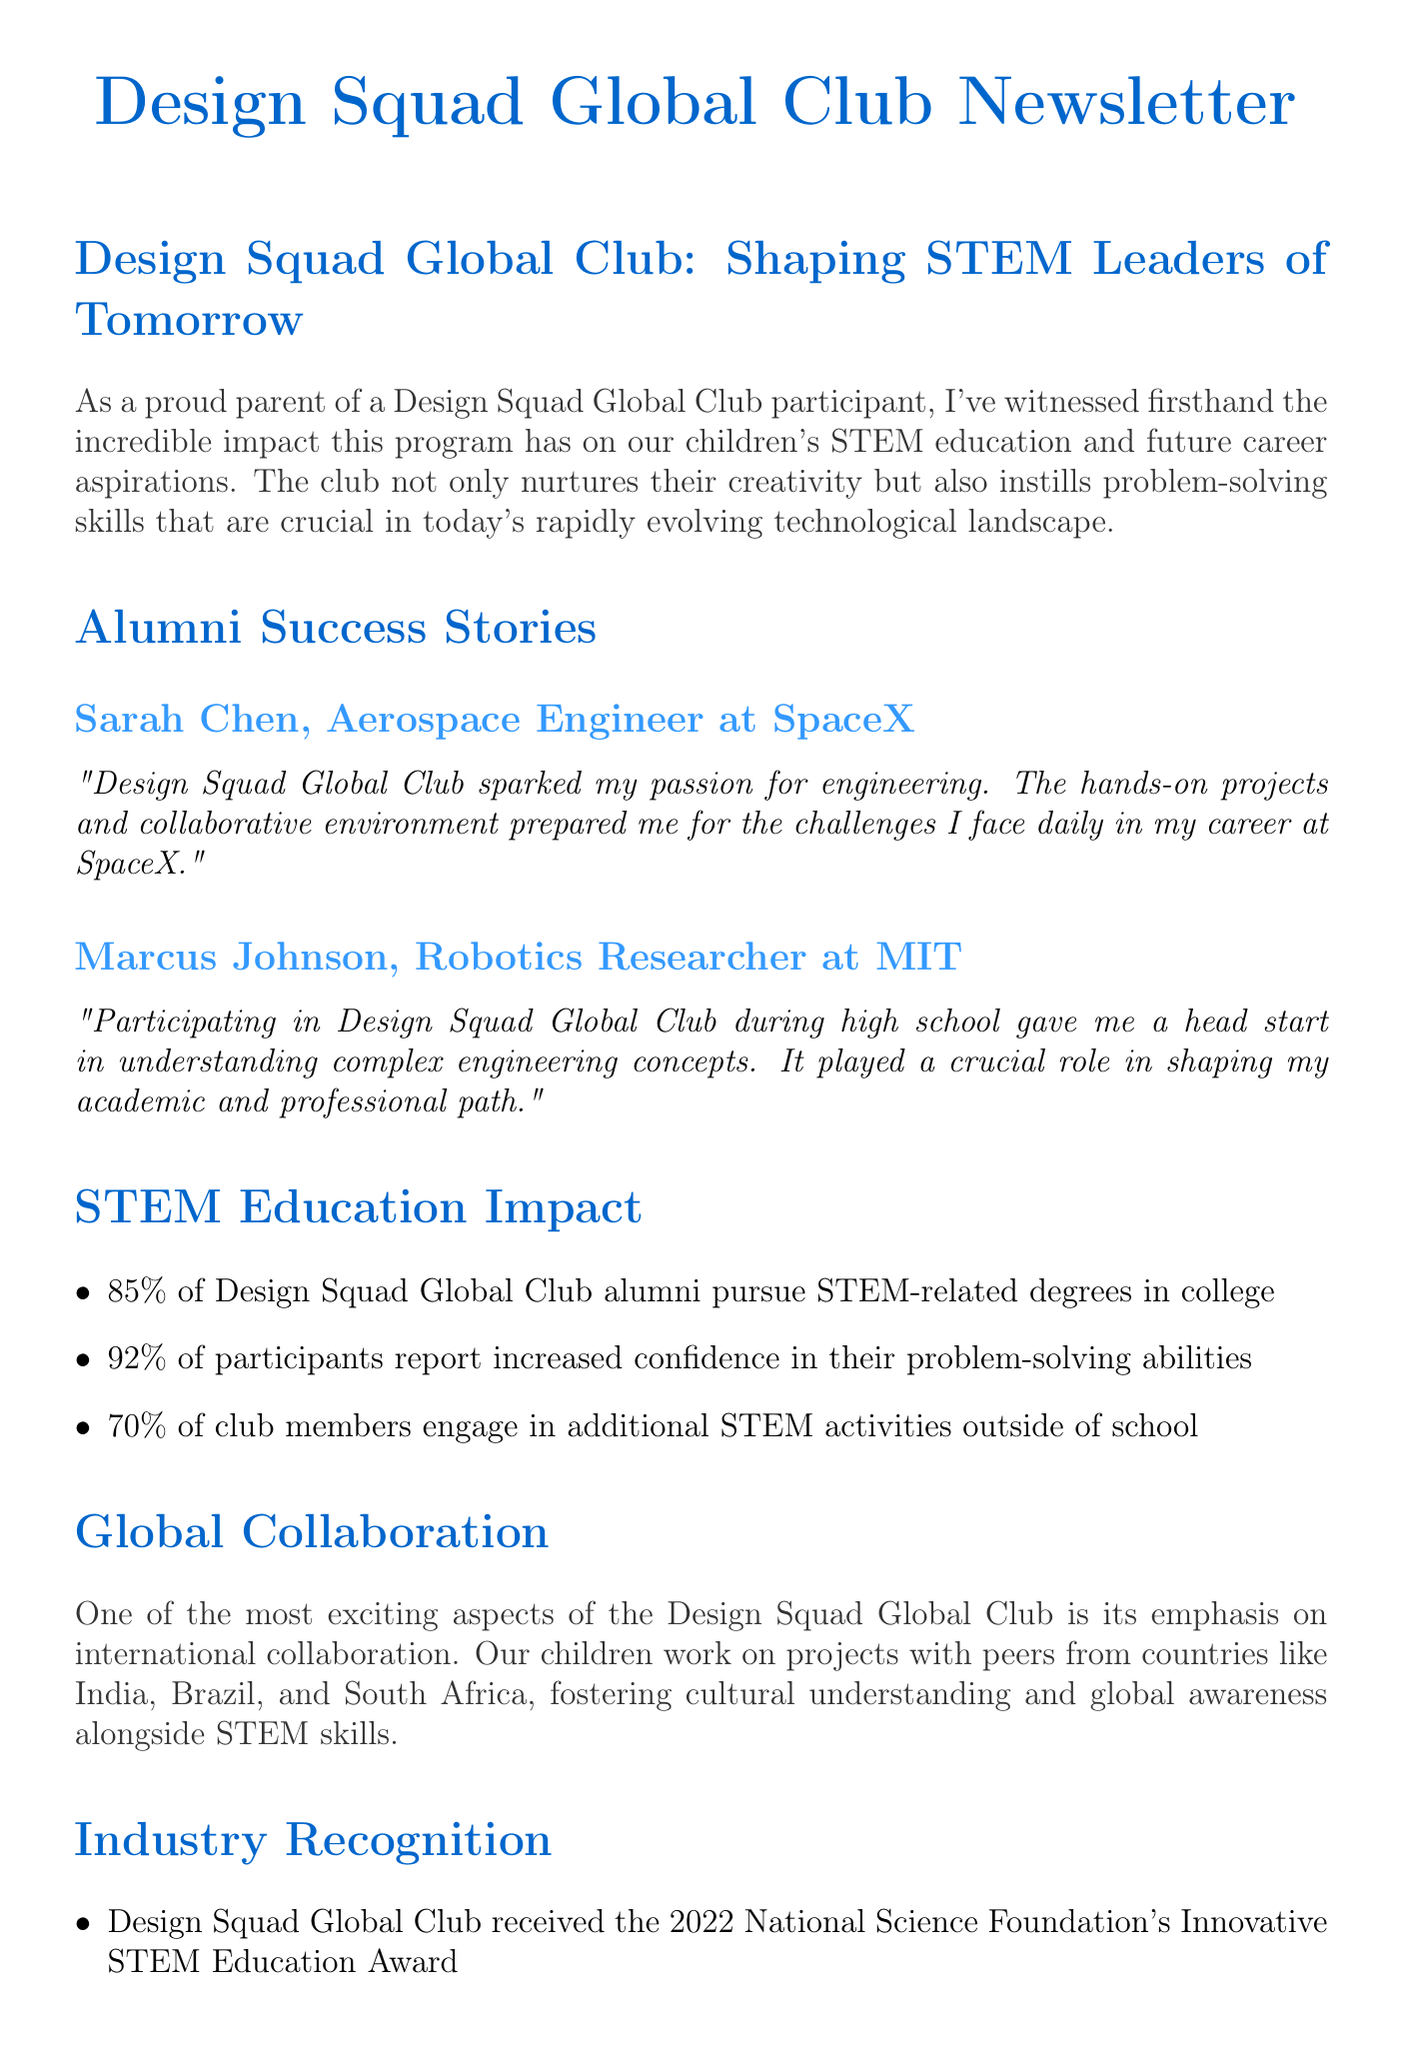What is the current position of Sarah Chen? The document states that Sarah Chen is an Aerospace Engineer at SpaceX.
Answer: Aerospace Engineer at SpaceX What percentage of alumni pursue STEM-related degrees? The newsletter indicates that 85% of Design Squad Global Club alumni pursue STEM-related degrees in college.
Answer: 85% Which company partnered with the Design Squad Global Club for the 'Design for Space' challenge? The document mentions that the Design Squad Global Club partnered with NASA for this challenge.
Answer: NASA What skill do 92% of participants report having increased? The newsletter notes that 92% of participants report increased confidence in their problem-solving abilities.
Answer: Problem-solving abilities How many upcoming events are listed in the Future Initiatives section? There are three upcoming events mentioned in the Future Initiatives section of the document.
Answer: Three What is one outcome parents have witnessed in their children? The newsletter describes that parents have seen remarkable growth in their children's confidence, creativity, and critical thinking skills.
Answer: Growth in confidence What is the title of the newsletter? The document provides the title "Design Squad Global Club Newsletter."
Answer: Design Squad Global Club Newsletter In which year did the Design Squad Global Club receive the Innovative STEM Education Award? According to the document, the award was received in 2022.
Answer: 2022 